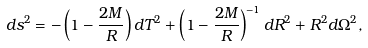<formula> <loc_0><loc_0><loc_500><loc_500>d s ^ { 2 } = - \left ( 1 - \frac { 2 M } { R } \right ) d T ^ { 2 } + \left ( 1 - \frac { 2 M } { R } \right ) ^ { - 1 } d R ^ { 2 } + R ^ { 2 } d \Omega ^ { 2 } ,</formula> 